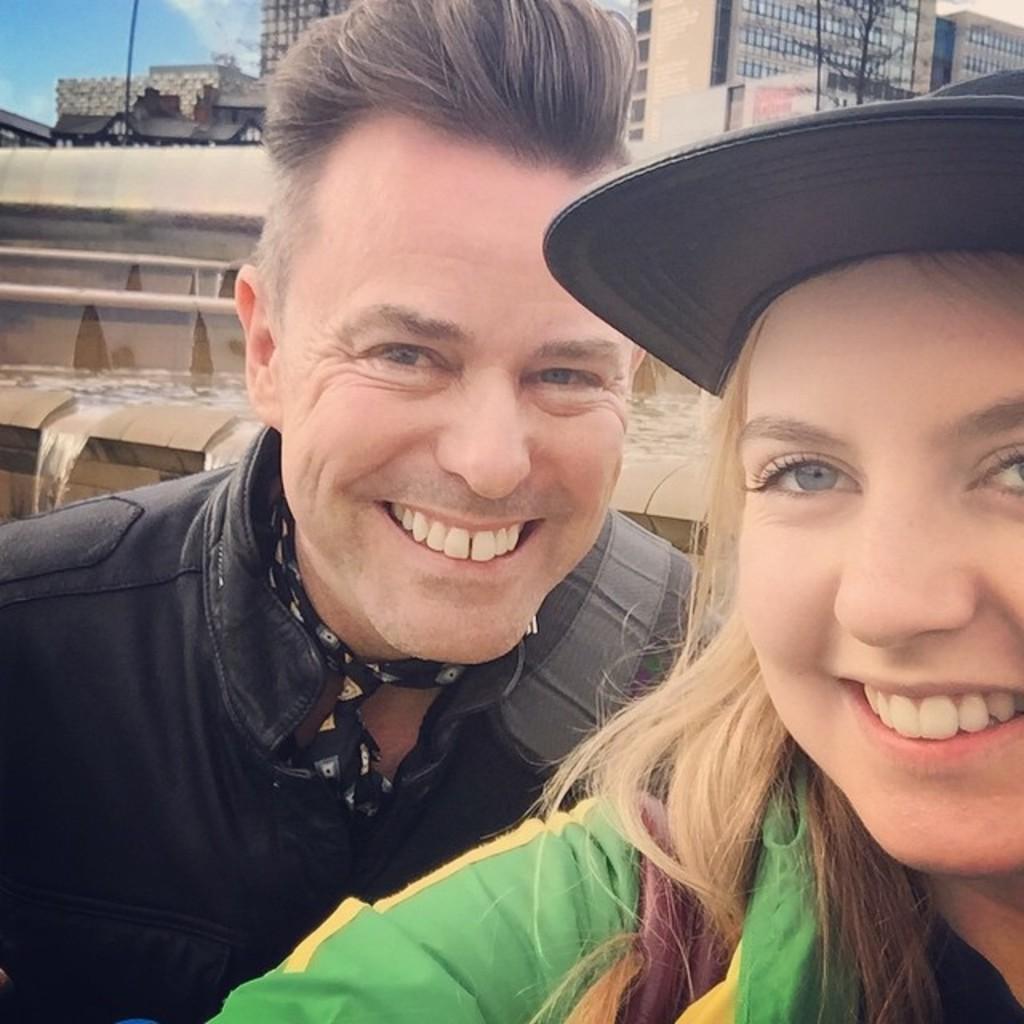Could you give a brief overview of what you see in this image? This is the man and woman smiling. I can see the water flowing. In the background, I can see the buildings. This looks like a tree. 